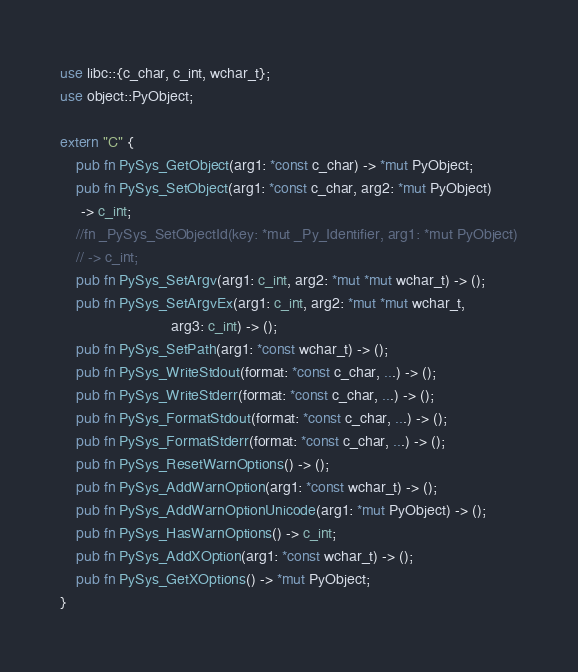<code> <loc_0><loc_0><loc_500><loc_500><_Rust_>use libc::{c_char, c_int, wchar_t};
use object::PyObject;

extern "C" {
    pub fn PySys_GetObject(arg1: *const c_char) -> *mut PyObject;
    pub fn PySys_SetObject(arg1: *const c_char, arg2: *mut PyObject)
     -> c_int;
    //fn _PySys_SetObjectId(key: *mut _Py_Identifier, arg1: *mut PyObject)
    // -> c_int;
    pub fn PySys_SetArgv(arg1: c_int, arg2: *mut *mut wchar_t) -> ();
    pub fn PySys_SetArgvEx(arg1: c_int, arg2: *mut *mut wchar_t,
                           arg3: c_int) -> ();
    pub fn PySys_SetPath(arg1: *const wchar_t) -> ();
    pub fn PySys_WriteStdout(format: *const c_char, ...) -> ();
    pub fn PySys_WriteStderr(format: *const c_char, ...) -> ();
    pub fn PySys_FormatStdout(format: *const c_char, ...) -> ();
    pub fn PySys_FormatStderr(format: *const c_char, ...) -> ();
    pub fn PySys_ResetWarnOptions() -> ();
    pub fn PySys_AddWarnOption(arg1: *const wchar_t) -> ();
    pub fn PySys_AddWarnOptionUnicode(arg1: *mut PyObject) -> ();
    pub fn PySys_HasWarnOptions() -> c_int;
    pub fn PySys_AddXOption(arg1: *const wchar_t) -> ();
    pub fn PySys_GetXOptions() -> *mut PyObject;
}

</code> 